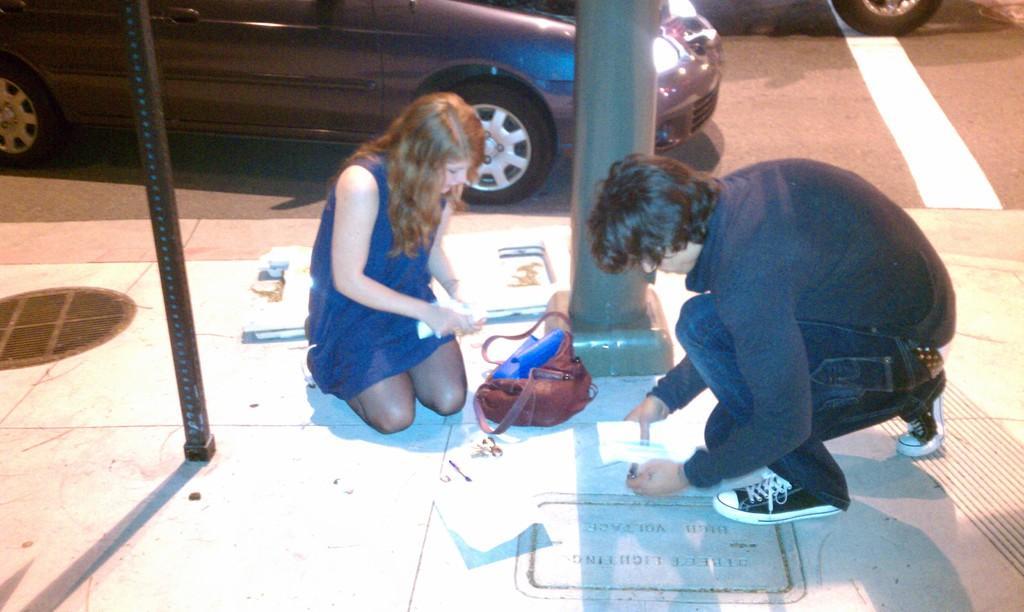In one or two sentences, can you explain what this image depicts? In the center of the image we can see two people are sitting on their knees and holding the papers and also we can see a bag and text. At the bottom of the image we can see the floor, poles. At the top of the image we can see the road and cars. 